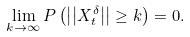<formula> <loc_0><loc_0><loc_500><loc_500>\lim _ { k \rightarrow \infty } P \left ( \left | \left | X _ { t } ^ { \delta } \right | \right | \geq k \right ) = 0 .</formula> 